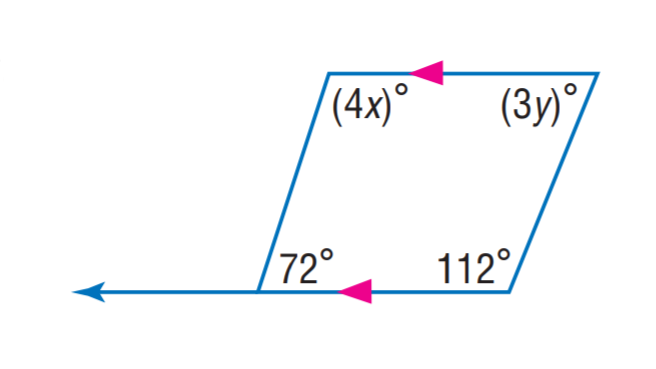Question: Find x.
Choices:
A. 24
B. 27
C. 72
D. 112
Answer with the letter. Answer: B 